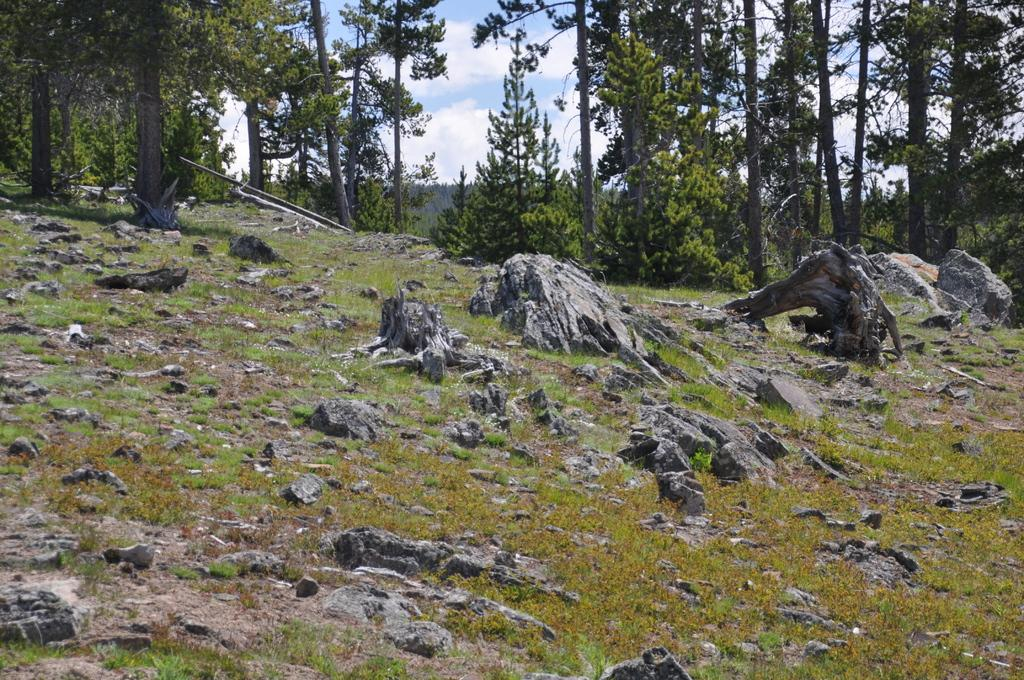What type of vegetation can be seen in the image? There is grass in the image. What other objects or features can be seen in the image? There are rocks in the image. What can be seen in the background of the image? There are trees and clouds in the background of the image. What part of the natural environment is visible in the image? The sky is visible in the background of the image. What beginner magic trick is being performed in the image? There is no magic trick or any indication of a magic performance in the image. 